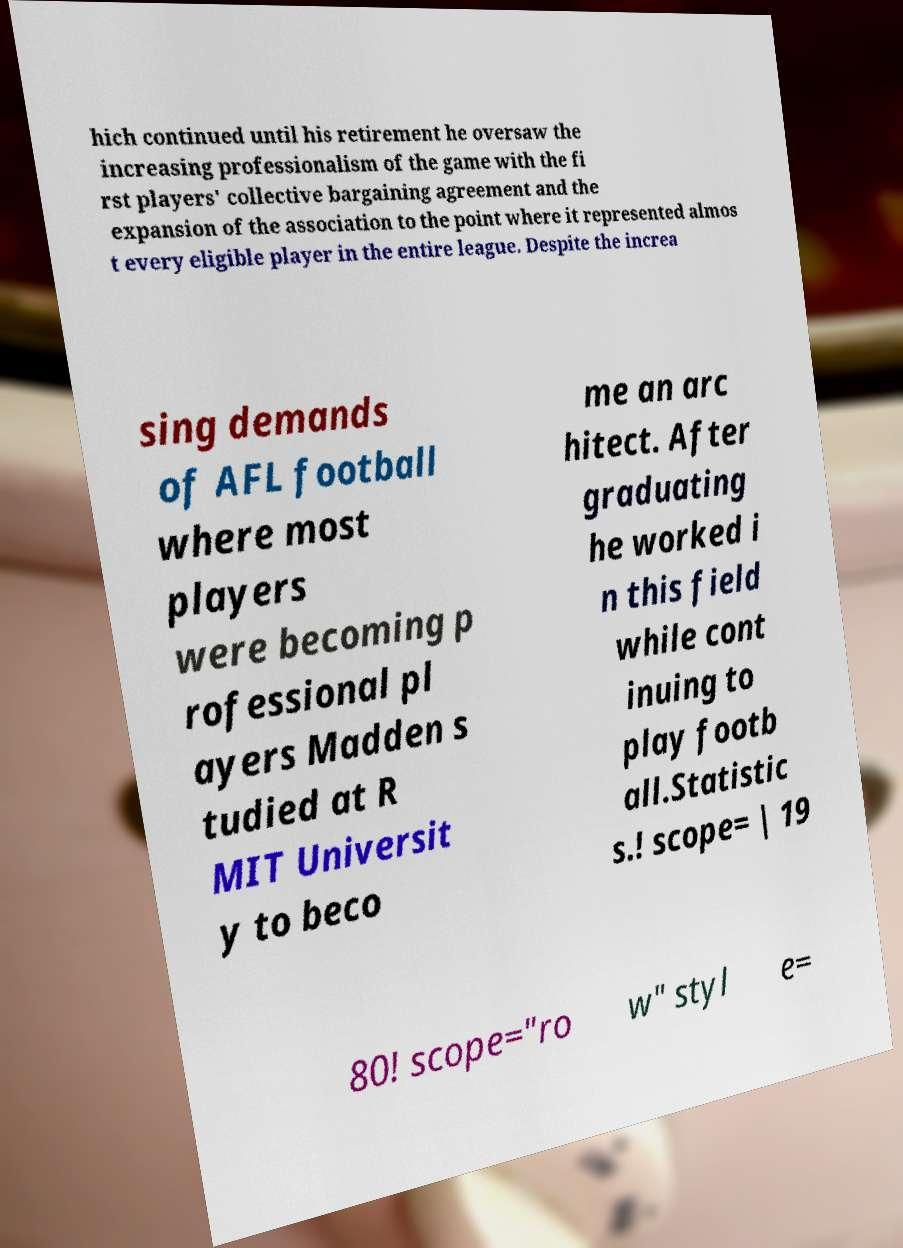Could you assist in decoding the text presented in this image and type it out clearly? hich continued until his retirement he oversaw the increasing professionalism of the game with the fi rst players' collective bargaining agreement and the expansion of the association to the point where it represented almos t every eligible player in the entire league. Despite the increa sing demands of AFL football where most players were becoming p rofessional pl ayers Madden s tudied at R MIT Universit y to beco me an arc hitect. After graduating he worked i n this field while cont inuing to play footb all.Statistic s.! scope= | 19 80! scope="ro w" styl e= 